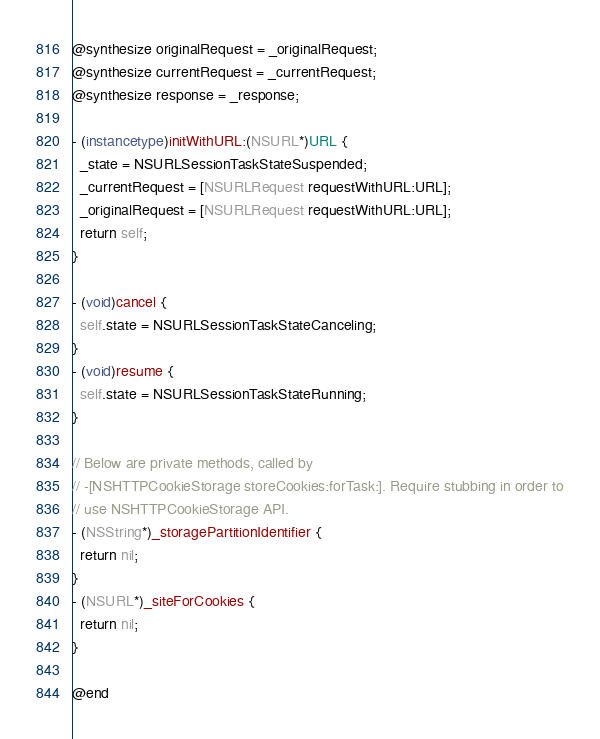<code> <loc_0><loc_0><loc_500><loc_500><_ObjectiveC_>@synthesize originalRequest = _originalRequest;
@synthesize currentRequest = _currentRequest;
@synthesize response = _response;

- (instancetype)initWithURL:(NSURL*)URL {
  _state = NSURLSessionTaskStateSuspended;
  _currentRequest = [NSURLRequest requestWithURL:URL];
  _originalRequest = [NSURLRequest requestWithURL:URL];
  return self;
}

- (void)cancel {
  self.state = NSURLSessionTaskStateCanceling;
}
- (void)resume {
  self.state = NSURLSessionTaskStateRunning;
}

// Below are private methods, called by
// -[NSHTTPCookieStorage storeCookies:forTask:]. Require stubbing in order to
// use NSHTTPCookieStorage API.
- (NSString*)_storagePartitionIdentifier {
  return nil;
}
- (NSURL*)_siteForCookies {
  return nil;
}

@end
</code> 